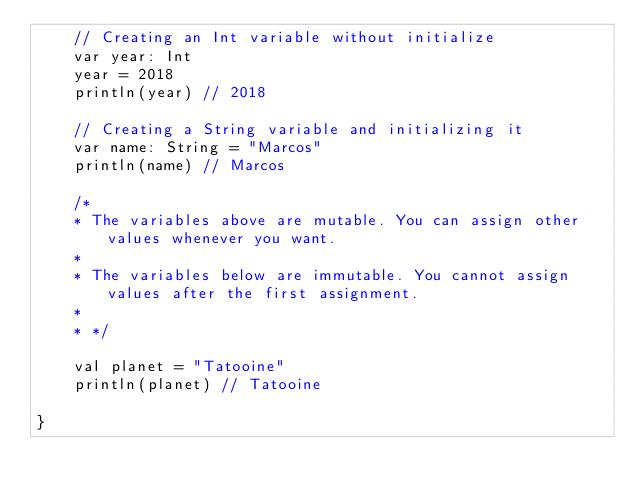<code> <loc_0><loc_0><loc_500><loc_500><_Kotlin_>    // Creating an Int variable without initialize
    var year: Int
    year = 2018
    println(year) // 2018

    // Creating a String variable and initializing it
    var name: String = "Marcos"
    println(name) // Marcos

    /*
    * The variables above are mutable. You can assign other values whenever you want.
    *
    * The variables below are immutable. You cannot assign values after the first assignment.
    *
    * */

    val planet = "Tatooine"
    println(planet) // Tatooine

}</code> 